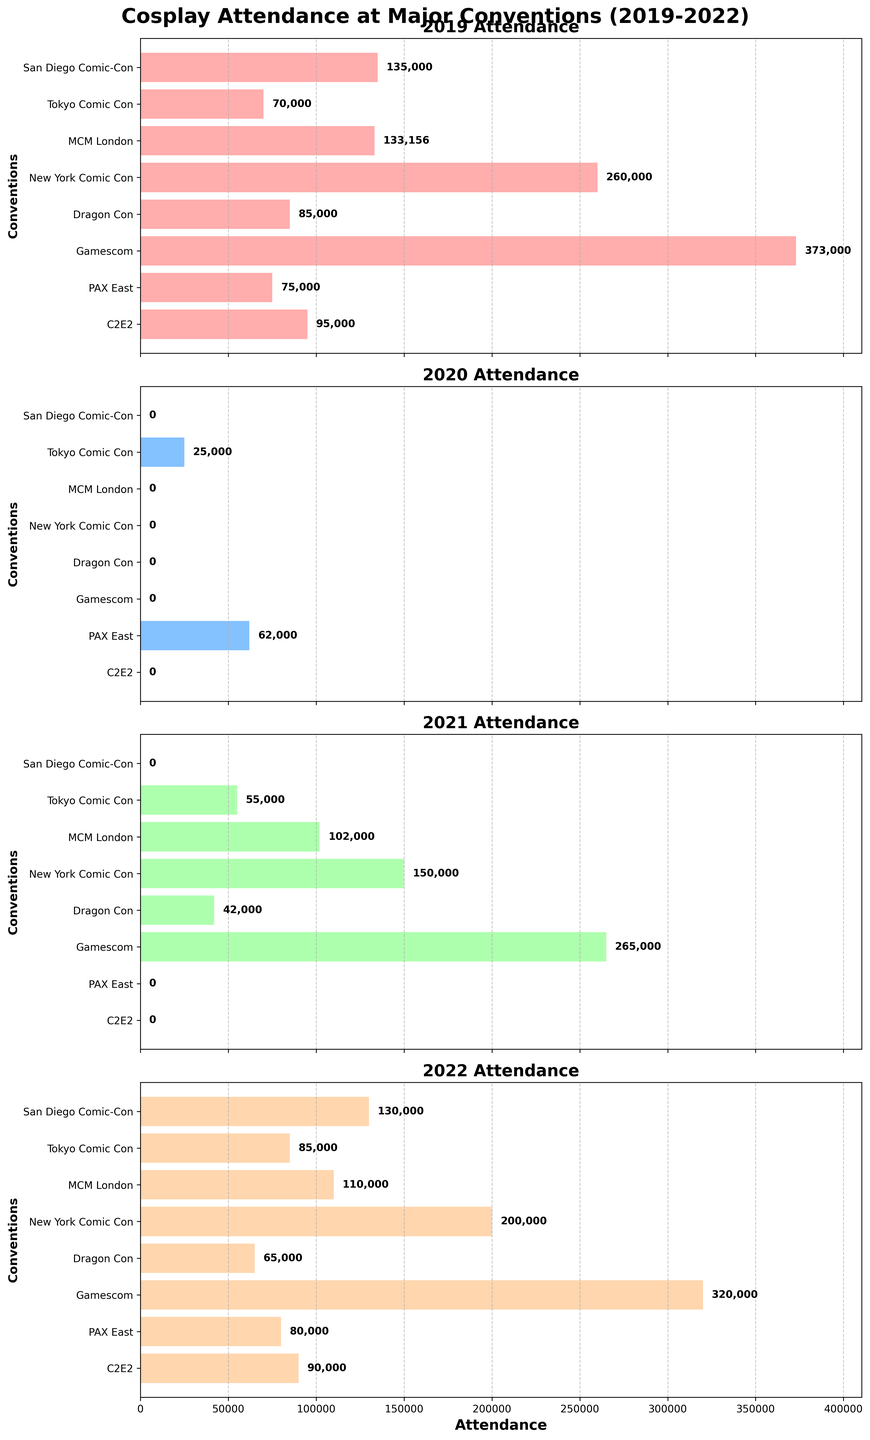Which convention had the highest attendance in 2019? Looking at the 2019 subplot, we see that New York Comic Con has the tallest bar, indicating the highest attendance.
Answer: New York Comic Con What is the trend in attendance for Tokyo Comic Con from 2019 to 2022? Tokyo Comic Con's attendance starts at 70,000 in 2019, drops to 25,000 in 2020, rises to 55,000 in 2021, and then increases further to 85,000 in 2022.
Answer: Decrease, increase, increase Which year had the least total attendance across all conventions? By summing the attendance numbers for each year:
  - 2019: 135,000 + 70,000 + 133,156 + 260,000 + 85,000 + 373,000 + 75,000 + 95,000
  - 2020: 0 + 25,000 + 0 + 0 + 0 + 0 + 62,000 + 0
  - 2021: 0 + 55,000 + 102,000 + 150,000 + 42,000 + 265,000 + 0 + 0
  - 2022: 130,000 + 85,000 + 110,000 + 200,000 + 65,000 + 320,000 + 80,000 + 90,000
  Summing these: 
  - 2019: 1,226,156
  - 2020: 87,000
  - 2021: 614,000
  - 2022: 1,080,000
  2020 has the least total attendance.
Answer: 2020 What was the impact of the COVID-19 pandemic on MCM London Comic Con's attendance? MCM London Comic Con had 133,156 attendees in 2019, 0 attendees in 2020, 102,000 in 2021, and 110,000 in 2022. The lack of attendance in 2020 and decreased numbers in 2021 show a significant impact.
Answer: Drastic decrease in 2020, partial recovery in 2021 Which convention showed the most consistent attendance from 2019 to 2022? Examining the bars for each year in each subplot, San Diego Comic-Con shows relatively consistent attendance with a small drop due to COVID-19 and recovery in 2022.
Answer: San Diego Comic-Con Compare the attendance numbers of Gamescom and Dragon Con in 2022. Which one was higher? In the 2022 subplot, Gamescom has a bar that extends to 320,000, whereas Dragon Con's bar extends to 65,000. So, Gamescom's attendance was higher.
Answer: Gamescom By how much did New York Comic Con’s attendance decrease from 2019 to 2022? New York Comic Con's attendance was 260,000 in 2019 and 200,000 in 2022. The difference is 260,000 - 200,000 = 60,000.
Answer: 60,000 How did the attendance of PAX East change from 2020 to 2022? PAX East had 62,000 attendees in 2020 and increased to 80,000 in 2022.
Answer: Increased by 18,000 